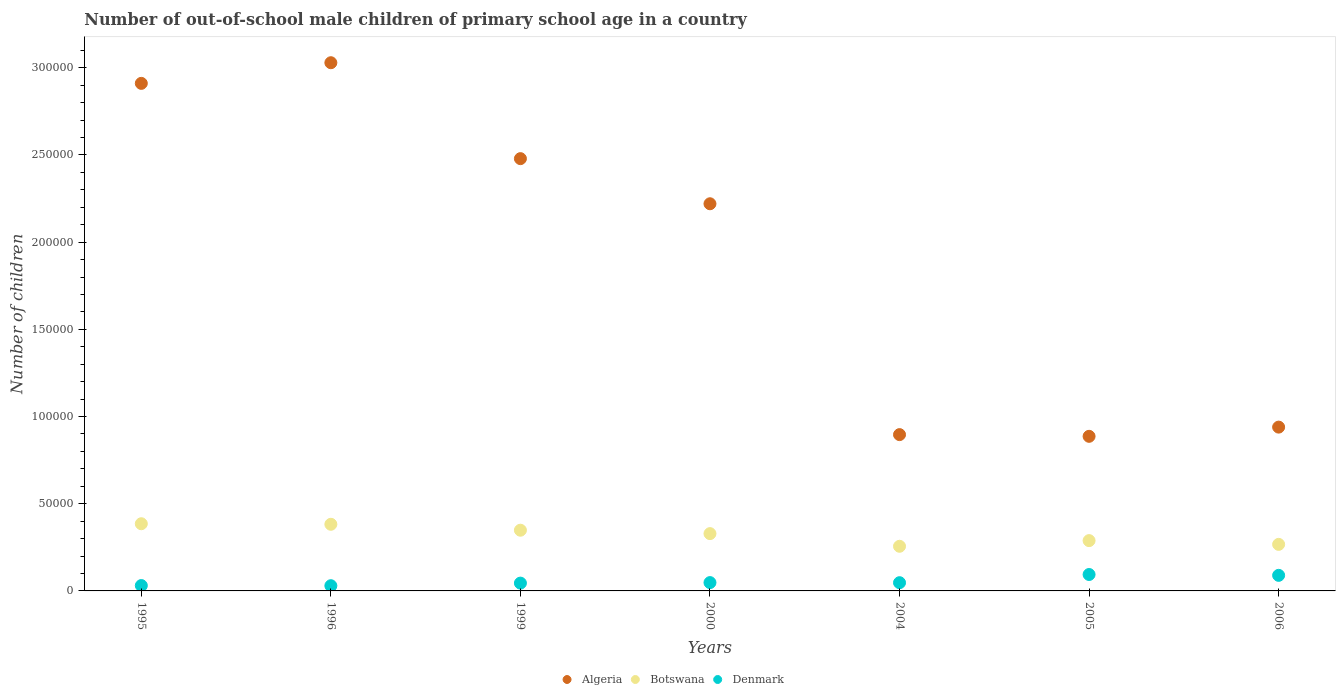How many different coloured dotlines are there?
Offer a very short reply. 3. Is the number of dotlines equal to the number of legend labels?
Offer a terse response. Yes. What is the number of out-of-school male children in Denmark in 1999?
Ensure brevity in your answer.  4475. Across all years, what is the maximum number of out-of-school male children in Botswana?
Provide a succinct answer. 3.85e+04. Across all years, what is the minimum number of out-of-school male children in Denmark?
Ensure brevity in your answer.  2986. In which year was the number of out-of-school male children in Algeria minimum?
Ensure brevity in your answer.  2005. What is the total number of out-of-school male children in Botswana in the graph?
Provide a short and direct response. 2.26e+05. What is the difference between the number of out-of-school male children in Denmark in 2004 and that in 2006?
Make the answer very short. -4213. What is the difference between the number of out-of-school male children in Denmark in 2005 and the number of out-of-school male children in Botswana in 1996?
Offer a terse response. -2.88e+04. What is the average number of out-of-school male children in Algeria per year?
Offer a very short reply. 1.91e+05. In the year 1996, what is the difference between the number of out-of-school male children in Denmark and number of out-of-school male children in Algeria?
Ensure brevity in your answer.  -3.00e+05. What is the ratio of the number of out-of-school male children in Denmark in 1995 to that in 2005?
Your response must be concise. 0.33. Is the number of out-of-school male children in Algeria in 2000 less than that in 2004?
Provide a succinct answer. No. What is the difference between the highest and the second highest number of out-of-school male children in Algeria?
Give a very brief answer. 1.18e+04. What is the difference between the highest and the lowest number of out-of-school male children in Denmark?
Offer a terse response. 6429. In how many years, is the number of out-of-school male children in Botswana greater than the average number of out-of-school male children in Botswana taken over all years?
Give a very brief answer. 4. Does the number of out-of-school male children in Algeria monotonically increase over the years?
Provide a succinct answer. No. How many dotlines are there?
Offer a very short reply. 3. What is the difference between two consecutive major ticks on the Y-axis?
Ensure brevity in your answer.  5.00e+04. Does the graph contain any zero values?
Ensure brevity in your answer.  No. Does the graph contain grids?
Ensure brevity in your answer.  No. Where does the legend appear in the graph?
Offer a very short reply. Bottom center. How many legend labels are there?
Provide a succinct answer. 3. How are the legend labels stacked?
Your response must be concise. Horizontal. What is the title of the graph?
Your response must be concise. Number of out-of-school male children of primary school age in a country. Does "Latin America(all income levels)" appear as one of the legend labels in the graph?
Provide a short and direct response. No. What is the label or title of the X-axis?
Give a very brief answer. Years. What is the label or title of the Y-axis?
Make the answer very short. Number of children. What is the Number of children of Algeria in 1995?
Offer a very short reply. 2.91e+05. What is the Number of children of Botswana in 1995?
Ensure brevity in your answer.  3.85e+04. What is the Number of children of Denmark in 1995?
Keep it short and to the point. 3071. What is the Number of children of Algeria in 1996?
Provide a succinct answer. 3.03e+05. What is the Number of children in Botswana in 1996?
Give a very brief answer. 3.82e+04. What is the Number of children of Denmark in 1996?
Your answer should be compact. 2986. What is the Number of children in Algeria in 1999?
Give a very brief answer. 2.48e+05. What is the Number of children of Botswana in 1999?
Provide a succinct answer. 3.48e+04. What is the Number of children of Denmark in 1999?
Give a very brief answer. 4475. What is the Number of children of Algeria in 2000?
Your answer should be compact. 2.22e+05. What is the Number of children of Botswana in 2000?
Your answer should be compact. 3.29e+04. What is the Number of children in Denmark in 2000?
Provide a succinct answer. 4775. What is the Number of children of Algeria in 2004?
Your answer should be very brief. 8.96e+04. What is the Number of children in Botswana in 2004?
Ensure brevity in your answer.  2.56e+04. What is the Number of children in Denmark in 2004?
Ensure brevity in your answer.  4718. What is the Number of children in Algeria in 2005?
Make the answer very short. 8.86e+04. What is the Number of children in Botswana in 2005?
Your answer should be very brief. 2.88e+04. What is the Number of children of Denmark in 2005?
Provide a succinct answer. 9415. What is the Number of children of Algeria in 2006?
Offer a terse response. 9.39e+04. What is the Number of children in Botswana in 2006?
Keep it short and to the point. 2.67e+04. What is the Number of children of Denmark in 2006?
Provide a succinct answer. 8931. Across all years, what is the maximum Number of children of Algeria?
Ensure brevity in your answer.  3.03e+05. Across all years, what is the maximum Number of children of Botswana?
Your answer should be compact. 3.85e+04. Across all years, what is the maximum Number of children of Denmark?
Ensure brevity in your answer.  9415. Across all years, what is the minimum Number of children of Algeria?
Your answer should be compact. 8.86e+04. Across all years, what is the minimum Number of children of Botswana?
Ensure brevity in your answer.  2.56e+04. Across all years, what is the minimum Number of children of Denmark?
Offer a very short reply. 2986. What is the total Number of children of Algeria in the graph?
Provide a short and direct response. 1.34e+06. What is the total Number of children in Botswana in the graph?
Ensure brevity in your answer.  2.26e+05. What is the total Number of children in Denmark in the graph?
Provide a short and direct response. 3.84e+04. What is the difference between the Number of children of Algeria in 1995 and that in 1996?
Keep it short and to the point. -1.18e+04. What is the difference between the Number of children in Botswana in 1995 and that in 1996?
Provide a short and direct response. 314. What is the difference between the Number of children of Algeria in 1995 and that in 1999?
Provide a succinct answer. 4.32e+04. What is the difference between the Number of children of Botswana in 1995 and that in 1999?
Offer a terse response. 3712. What is the difference between the Number of children of Denmark in 1995 and that in 1999?
Offer a terse response. -1404. What is the difference between the Number of children of Algeria in 1995 and that in 2000?
Offer a very short reply. 6.90e+04. What is the difference between the Number of children of Botswana in 1995 and that in 2000?
Provide a succinct answer. 5669. What is the difference between the Number of children of Denmark in 1995 and that in 2000?
Provide a short and direct response. -1704. What is the difference between the Number of children of Algeria in 1995 and that in 2004?
Give a very brief answer. 2.01e+05. What is the difference between the Number of children of Botswana in 1995 and that in 2004?
Keep it short and to the point. 1.29e+04. What is the difference between the Number of children of Denmark in 1995 and that in 2004?
Provide a short and direct response. -1647. What is the difference between the Number of children in Algeria in 1995 and that in 2005?
Your answer should be compact. 2.02e+05. What is the difference between the Number of children of Botswana in 1995 and that in 2005?
Make the answer very short. 9678. What is the difference between the Number of children in Denmark in 1995 and that in 2005?
Give a very brief answer. -6344. What is the difference between the Number of children of Algeria in 1995 and that in 2006?
Offer a terse response. 1.97e+05. What is the difference between the Number of children in Botswana in 1995 and that in 2006?
Offer a terse response. 1.18e+04. What is the difference between the Number of children of Denmark in 1995 and that in 2006?
Offer a very short reply. -5860. What is the difference between the Number of children in Algeria in 1996 and that in 1999?
Keep it short and to the point. 5.50e+04. What is the difference between the Number of children of Botswana in 1996 and that in 1999?
Make the answer very short. 3398. What is the difference between the Number of children of Denmark in 1996 and that in 1999?
Offer a very short reply. -1489. What is the difference between the Number of children in Algeria in 1996 and that in 2000?
Provide a short and direct response. 8.09e+04. What is the difference between the Number of children in Botswana in 1996 and that in 2000?
Provide a succinct answer. 5355. What is the difference between the Number of children of Denmark in 1996 and that in 2000?
Provide a succinct answer. -1789. What is the difference between the Number of children in Algeria in 1996 and that in 2004?
Your answer should be very brief. 2.13e+05. What is the difference between the Number of children in Botswana in 1996 and that in 2004?
Give a very brief answer. 1.26e+04. What is the difference between the Number of children in Denmark in 1996 and that in 2004?
Your answer should be very brief. -1732. What is the difference between the Number of children in Algeria in 1996 and that in 2005?
Provide a short and direct response. 2.14e+05. What is the difference between the Number of children of Botswana in 1996 and that in 2005?
Provide a short and direct response. 9364. What is the difference between the Number of children of Denmark in 1996 and that in 2005?
Provide a succinct answer. -6429. What is the difference between the Number of children of Algeria in 1996 and that in 2006?
Provide a short and direct response. 2.09e+05. What is the difference between the Number of children of Botswana in 1996 and that in 2006?
Ensure brevity in your answer.  1.15e+04. What is the difference between the Number of children in Denmark in 1996 and that in 2006?
Provide a short and direct response. -5945. What is the difference between the Number of children of Algeria in 1999 and that in 2000?
Make the answer very short. 2.59e+04. What is the difference between the Number of children of Botswana in 1999 and that in 2000?
Your answer should be very brief. 1957. What is the difference between the Number of children in Denmark in 1999 and that in 2000?
Give a very brief answer. -300. What is the difference between the Number of children in Algeria in 1999 and that in 2004?
Ensure brevity in your answer.  1.58e+05. What is the difference between the Number of children of Botswana in 1999 and that in 2004?
Ensure brevity in your answer.  9215. What is the difference between the Number of children in Denmark in 1999 and that in 2004?
Keep it short and to the point. -243. What is the difference between the Number of children in Algeria in 1999 and that in 2005?
Provide a succinct answer. 1.59e+05. What is the difference between the Number of children of Botswana in 1999 and that in 2005?
Your response must be concise. 5966. What is the difference between the Number of children in Denmark in 1999 and that in 2005?
Your answer should be compact. -4940. What is the difference between the Number of children of Algeria in 1999 and that in 2006?
Make the answer very short. 1.54e+05. What is the difference between the Number of children in Botswana in 1999 and that in 2006?
Offer a terse response. 8118. What is the difference between the Number of children in Denmark in 1999 and that in 2006?
Give a very brief answer. -4456. What is the difference between the Number of children of Algeria in 2000 and that in 2004?
Offer a very short reply. 1.32e+05. What is the difference between the Number of children in Botswana in 2000 and that in 2004?
Offer a terse response. 7258. What is the difference between the Number of children in Denmark in 2000 and that in 2004?
Keep it short and to the point. 57. What is the difference between the Number of children in Algeria in 2000 and that in 2005?
Keep it short and to the point. 1.33e+05. What is the difference between the Number of children of Botswana in 2000 and that in 2005?
Offer a very short reply. 4009. What is the difference between the Number of children of Denmark in 2000 and that in 2005?
Provide a succinct answer. -4640. What is the difference between the Number of children of Algeria in 2000 and that in 2006?
Your answer should be compact. 1.28e+05. What is the difference between the Number of children of Botswana in 2000 and that in 2006?
Provide a short and direct response. 6161. What is the difference between the Number of children of Denmark in 2000 and that in 2006?
Provide a short and direct response. -4156. What is the difference between the Number of children in Algeria in 2004 and that in 2005?
Offer a terse response. 978. What is the difference between the Number of children of Botswana in 2004 and that in 2005?
Your answer should be very brief. -3249. What is the difference between the Number of children of Denmark in 2004 and that in 2005?
Keep it short and to the point. -4697. What is the difference between the Number of children of Algeria in 2004 and that in 2006?
Make the answer very short. -4301. What is the difference between the Number of children of Botswana in 2004 and that in 2006?
Your answer should be very brief. -1097. What is the difference between the Number of children of Denmark in 2004 and that in 2006?
Make the answer very short. -4213. What is the difference between the Number of children in Algeria in 2005 and that in 2006?
Make the answer very short. -5279. What is the difference between the Number of children of Botswana in 2005 and that in 2006?
Keep it short and to the point. 2152. What is the difference between the Number of children in Denmark in 2005 and that in 2006?
Ensure brevity in your answer.  484. What is the difference between the Number of children in Algeria in 1995 and the Number of children in Botswana in 1996?
Keep it short and to the point. 2.53e+05. What is the difference between the Number of children in Algeria in 1995 and the Number of children in Denmark in 1996?
Keep it short and to the point. 2.88e+05. What is the difference between the Number of children in Botswana in 1995 and the Number of children in Denmark in 1996?
Give a very brief answer. 3.55e+04. What is the difference between the Number of children in Algeria in 1995 and the Number of children in Botswana in 1999?
Ensure brevity in your answer.  2.56e+05. What is the difference between the Number of children in Algeria in 1995 and the Number of children in Denmark in 1999?
Your answer should be very brief. 2.87e+05. What is the difference between the Number of children in Botswana in 1995 and the Number of children in Denmark in 1999?
Your response must be concise. 3.41e+04. What is the difference between the Number of children of Algeria in 1995 and the Number of children of Botswana in 2000?
Provide a succinct answer. 2.58e+05. What is the difference between the Number of children of Algeria in 1995 and the Number of children of Denmark in 2000?
Your answer should be very brief. 2.86e+05. What is the difference between the Number of children of Botswana in 1995 and the Number of children of Denmark in 2000?
Keep it short and to the point. 3.38e+04. What is the difference between the Number of children in Algeria in 1995 and the Number of children in Botswana in 2004?
Your answer should be very brief. 2.65e+05. What is the difference between the Number of children of Algeria in 1995 and the Number of children of Denmark in 2004?
Offer a terse response. 2.86e+05. What is the difference between the Number of children in Botswana in 1995 and the Number of children in Denmark in 2004?
Give a very brief answer. 3.38e+04. What is the difference between the Number of children in Algeria in 1995 and the Number of children in Botswana in 2005?
Give a very brief answer. 2.62e+05. What is the difference between the Number of children in Algeria in 1995 and the Number of children in Denmark in 2005?
Keep it short and to the point. 2.82e+05. What is the difference between the Number of children in Botswana in 1995 and the Number of children in Denmark in 2005?
Your response must be concise. 2.91e+04. What is the difference between the Number of children in Algeria in 1995 and the Number of children in Botswana in 2006?
Provide a short and direct response. 2.64e+05. What is the difference between the Number of children of Algeria in 1995 and the Number of children of Denmark in 2006?
Provide a succinct answer. 2.82e+05. What is the difference between the Number of children of Botswana in 1995 and the Number of children of Denmark in 2006?
Your answer should be compact. 2.96e+04. What is the difference between the Number of children of Algeria in 1996 and the Number of children of Botswana in 1999?
Provide a short and direct response. 2.68e+05. What is the difference between the Number of children of Algeria in 1996 and the Number of children of Denmark in 1999?
Give a very brief answer. 2.98e+05. What is the difference between the Number of children in Botswana in 1996 and the Number of children in Denmark in 1999?
Provide a succinct answer. 3.37e+04. What is the difference between the Number of children of Algeria in 1996 and the Number of children of Botswana in 2000?
Keep it short and to the point. 2.70e+05. What is the difference between the Number of children of Algeria in 1996 and the Number of children of Denmark in 2000?
Your answer should be very brief. 2.98e+05. What is the difference between the Number of children in Botswana in 1996 and the Number of children in Denmark in 2000?
Your response must be concise. 3.34e+04. What is the difference between the Number of children of Algeria in 1996 and the Number of children of Botswana in 2004?
Offer a very short reply. 2.77e+05. What is the difference between the Number of children in Algeria in 1996 and the Number of children in Denmark in 2004?
Ensure brevity in your answer.  2.98e+05. What is the difference between the Number of children in Botswana in 1996 and the Number of children in Denmark in 2004?
Keep it short and to the point. 3.35e+04. What is the difference between the Number of children in Algeria in 1996 and the Number of children in Botswana in 2005?
Keep it short and to the point. 2.74e+05. What is the difference between the Number of children of Algeria in 1996 and the Number of children of Denmark in 2005?
Your answer should be very brief. 2.93e+05. What is the difference between the Number of children of Botswana in 1996 and the Number of children of Denmark in 2005?
Keep it short and to the point. 2.88e+04. What is the difference between the Number of children of Algeria in 1996 and the Number of children of Botswana in 2006?
Keep it short and to the point. 2.76e+05. What is the difference between the Number of children of Algeria in 1996 and the Number of children of Denmark in 2006?
Your answer should be very brief. 2.94e+05. What is the difference between the Number of children in Botswana in 1996 and the Number of children in Denmark in 2006?
Make the answer very short. 2.93e+04. What is the difference between the Number of children in Algeria in 1999 and the Number of children in Botswana in 2000?
Your answer should be compact. 2.15e+05. What is the difference between the Number of children in Algeria in 1999 and the Number of children in Denmark in 2000?
Ensure brevity in your answer.  2.43e+05. What is the difference between the Number of children of Botswana in 1999 and the Number of children of Denmark in 2000?
Your answer should be very brief. 3.00e+04. What is the difference between the Number of children in Algeria in 1999 and the Number of children in Botswana in 2004?
Keep it short and to the point. 2.22e+05. What is the difference between the Number of children in Algeria in 1999 and the Number of children in Denmark in 2004?
Keep it short and to the point. 2.43e+05. What is the difference between the Number of children in Botswana in 1999 and the Number of children in Denmark in 2004?
Ensure brevity in your answer.  3.01e+04. What is the difference between the Number of children of Algeria in 1999 and the Number of children of Botswana in 2005?
Your answer should be compact. 2.19e+05. What is the difference between the Number of children in Algeria in 1999 and the Number of children in Denmark in 2005?
Offer a very short reply. 2.38e+05. What is the difference between the Number of children in Botswana in 1999 and the Number of children in Denmark in 2005?
Your answer should be compact. 2.54e+04. What is the difference between the Number of children in Algeria in 1999 and the Number of children in Botswana in 2006?
Your answer should be very brief. 2.21e+05. What is the difference between the Number of children of Algeria in 1999 and the Number of children of Denmark in 2006?
Your answer should be very brief. 2.39e+05. What is the difference between the Number of children of Botswana in 1999 and the Number of children of Denmark in 2006?
Provide a short and direct response. 2.59e+04. What is the difference between the Number of children in Algeria in 2000 and the Number of children in Botswana in 2004?
Give a very brief answer. 1.96e+05. What is the difference between the Number of children in Algeria in 2000 and the Number of children in Denmark in 2004?
Give a very brief answer. 2.17e+05. What is the difference between the Number of children of Botswana in 2000 and the Number of children of Denmark in 2004?
Make the answer very short. 2.81e+04. What is the difference between the Number of children of Algeria in 2000 and the Number of children of Botswana in 2005?
Provide a short and direct response. 1.93e+05. What is the difference between the Number of children in Algeria in 2000 and the Number of children in Denmark in 2005?
Make the answer very short. 2.13e+05. What is the difference between the Number of children of Botswana in 2000 and the Number of children of Denmark in 2005?
Offer a very short reply. 2.34e+04. What is the difference between the Number of children in Algeria in 2000 and the Number of children in Botswana in 2006?
Keep it short and to the point. 1.95e+05. What is the difference between the Number of children of Algeria in 2000 and the Number of children of Denmark in 2006?
Keep it short and to the point. 2.13e+05. What is the difference between the Number of children in Botswana in 2000 and the Number of children in Denmark in 2006?
Make the answer very short. 2.39e+04. What is the difference between the Number of children in Algeria in 2004 and the Number of children in Botswana in 2005?
Ensure brevity in your answer.  6.08e+04. What is the difference between the Number of children in Algeria in 2004 and the Number of children in Denmark in 2005?
Keep it short and to the point. 8.02e+04. What is the difference between the Number of children in Botswana in 2004 and the Number of children in Denmark in 2005?
Make the answer very short. 1.62e+04. What is the difference between the Number of children of Algeria in 2004 and the Number of children of Botswana in 2006?
Keep it short and to the point. 6.29e+04. What is the difference between the Number of children of Algeria in 2004 and the Number of children of Denmark in 2006?
Your response must be concise. 8.07e+04. What is the difference between the Number of children of Botswana in 2004 and the Number of children of Denmark in 2006?
Your response must be concise. 1.67e+04. What is the difference between the Number of children in Algeria in 2005 and the Number of children in Botswana in 2006?
Offer a terse response. 6.20e+04. What is the difference between the Number of children of Algeria in 2005 and the Number of children of Denmark in 2006?
Your answer should be compact. 7.97e+04. What is the difference between the Number of children in Botswana in 2005 and the Number of children in Denmark in 2006?
Ensure brevity in your answer.  1.99e+04. What is the average Number of children in Algeria per year?
Your answer should be compact. 1.91e+05. What is the average Number of children of Botswana per year?
Keep it short and to the point. 3.22e+04. What is the average Number of children in Denmark per year?
Provide a short and direct response. 5481.57. In the year 1995, what is the difference between the Number of children of Algeria and Number of children of Botswana?
Make the answer very short. 2.53e+05. In the year 1995, what is the difference between the Number of children of Algeria and Number of children of Denmark?
Make the answer very short. 2.88e+05. In the year 1995, what is the difference between the Number of children of Botswana and Number of children of Denmark?
Offer a very short reply. 3.55e+04. In the year 1996, what is the difference between the Number of children in Algeria and Number of children in Botswana?
Keep it short and to the point. 2.65e+05. In the year 1996, what is the difference between the Number of children of Algeria and Number of children of Denmark?
Your answer should be compact. 3.00e+05. In the year 1996, what is the difference between the Number of children of Botswana and Number of children of Denmark?
Ensure brevity in your answer.  3.52e+04. In the year 1999, what is the difference between the Number of children in Algeria and Number of children in Botswana?
Offer a terse response. 2.13e+05. In the year 1999, what is the difference between the Number of children of Algeria and Number of children of Denmark?
Provide a succinct answer. 2.43e+05. In the year 1999, what is the difference between the Number of children in Botswana and Number of children in Denmark?
Your response must be concise. 3.03e+04. In the year 2000, what is the difference between the Number of children in Algeria and Number of children in Botswana?
Ensure brevity in your answer.  1.89e+05. In the year 2000, what is the difference between the Number of children in Algeria and Number of children in Denmark?
Your answer should be very brief. 2.17e+05. In the year 2000, what is the difference between the Number of children in Botswana and Number of children in Denmark?
Provide a short and direct response. 2.81e+04. In the year 2004, what is the difference between the Number of children in Algeria and Number of children in Botswana?
Provide a short and direct response. 6.40e+04. In the year 2004, what is the difference between the Number of children of Algeria and Number of children of Denmark?
Your answer should be very brief. 8.49e+04. In the year 2004, what is the difference between the Number of children of Botswana and Number of children of Denmark?
Ensure brevity in your answer.  2.09e+04. In the year 2005, what is the difference between the Number of children of Algeria and Number of children of Botswana?
Your response must be concise. 5.98e+04. In the year 2005, what is the difference between the Number of children in Algeria and Number of children in Denmark?
Provide a succinct answer. 7.92e+04. In the year 2005, what is the difference between the Number of children of Botswana and Number of children of Denmark?
Offer a very short reply. 1.94e+04. In the year 2006, what is the difference between the Number of children in Algeria and Number of children in Botswana?
Offer a terse response. 6.72e+04. In the year 2006, what is the difference between the Number of children of Algeria and Number of children of Denmark?
Provide a succinct answer. 8.50e+04. In the year 2006, what is the difference between the Number of children in Botswana and Number of children in Denmark?
Ensure brevity in your answer.  1.78e+04. What is the ratio of the Number of children in Algeria in 1995 to that in 1996?
Keep it short and to the point. 0.96. What is the ratio of the Number of children of Botswana in 1995 to that in 1996?
Give a very brief answer. 1.01. What is the ratio of the Number of children in Denmark in 1995 to that in 1996?
Provide a short and direct response. 1.03. What is the ratio of the Number of children of Algeria in 1995 to that in 1999?
Keep it short and to the point. 1.17. What is the ratio of the Number of children of Botswana in 1995 to that in 1999?
Make the answer very short. 1.11. What is the ratio of the Number of children in Denmark in 1995 to that in 1999?
Keep it short and to the point. 0.69. What is the ratio of the Number of children in Algeria in 1995 to that in 2000?
Keep it short and to the point. 1.31. What is the ratio of the Number of children of Botswana in 1995 to that in 2000?
Keep it short and to the point. 1.17. What is the ratio of the Number of children of Denmark in 1995 to that in 2000?
Ensure brevity in your answer.  0.64. What is the ratio of the Number of children of Algeria in 1995 to that in 2004?
Keep it short and to the point. 3.25. What is the ratio of the Number of children of Botswana in 1995 to that in 2004?
Your response must be concise. 1.5. What is the ratio of the Number of children in Denmark in 1995 to that in 2004?
Give a very brief answer. 0.65. What is the ratio of the Number of children of Algeria in 1995 to that in 2005?
Your response must be concise. 3.28. What is the ratio of the Number of children of Botswana in 1995 to that in 2005?
Make the answer very short. 1.34. What is the ratio of the Number of children in Denmark in 1995 to that in 2005?
Give a very brief answer. 0.33. What is the ratio of the Number of children of Algeria in 1995 to that in 2006?
Make the answer very short. 3.1. What is the ratio of the Number of children in Botswana in 1995 to that in 2006?
Your response must be concise. 1.44. What is the ratio of the Number of children of Denmark in 1995 to that in 2006?
Your answer should be very brief. 0.34. What is the ratio of the Number of children of Algeria in 1996 to that in 1999?
Offer a terse response. 1.22. What is the ratio of the Number of children of Botswana in 1996 to that in 1999?
Make the answer very short. 1.1. What is the ratio of the Number of children of Denmark in 1996 to that in 1999?
Offer a terse response. 0.67. What is the ratio of the Number of children in Algeria in 1996 to that in 2000?
Provide a succinct answer. 1.36. What is the ratio of the Number of children in Botswana in 1996 to that in 2000?
Ensure brevity in your answer.  1.16. What is the ratio of the Number of children in Denmark in 1996 to that in 2000?
Offer a very short reply. 0.63. What is the ratio of the Number of children in Algeria in 1996 to that in 2004?
Offer a very short reply. 3.38. What is the ratio of the Number of children of Botswana in 1996 to that in 2004?
Offer a terse response. 1.49. What is the ratio of the Number of children in Denmark in 1996 to that in 2004?
Ensure brevity in your answer.  0.63. What is the ratio of the Number of children of Algeria in 1996 to that in 2005?
Provide a succinct answer. 3.42. What is the ratio of the Number of children in Botswana in 1996 to that in 2005?
Provide a short and direct response. 1.32. What is the ratio of the Number of children of Denmark in 1996 to that in 2005?
Your response must be concise. 0.32. What is the ratio of the Number of children in Algeria in 1996 to that in 2006?
Offer a terse response. 3.22. What is the ratio of the Number of children in Botswana in 1996 to that in 2006?
Offer a terse response. 1.43. What is the ratio of the Number of children in Denmark in 1996 to that in 2006?
Provide a succinct answer. 0.33. What is the ratio of the Number of children of Algeria in 1999 to that in 2000?
Ensure brevity in your answer.  1.12. What is the ratio of the Number of children in Botswana in 1999 to that in 2000?
Make the answer very short. 1.06. What is the ratio of the Number of children in Denmark in 1999 to that in 2000?
Your answer should be very brief. 0.94. What is the ratio of the Number of children of Algeria in 1999 to that in 2004?
Provide a succinct answer. 2.77. What is the ratio of the Number of children in Botswana in 1999 to that in 2004?
Keep it short and to the point. 1.36. What is the ratio of the Number of children of Denmark in 1999 to that in 2004?
Your answer should be very brief. 0.95. What is the ratio of the Number of children in Algeria in 1999 to that in 2005?
Provide a short and direct response. 2.8. What is the ratio of the Number of children of Botswana in 1999 to that in 2005?
Your answer should be compact. 1.21. What is the ratio of the Number of children in Denmark in 1999 to that in 2005?
Provide a succinct answer. 0.48. What is the ratio of the Number of children in Algeria in 1999 to that in 2006?
Give a very brief answer. 2.64. What is the ratio of the Number of children of Botswana in 1999 to that in 2006?
Provide a succinct answer. 1.3. What is the ratio of the Number of children of Denmark in 1999 to that in 2006?
Keep it short and to the point. 0.5. What is the ratio of the Number of children in Algeria in 2000 to that in 2004?
Offer a terse response. 2.48. What is the ratio of the Number of children of Botswana in 2000 to that in 2004?
Your answer should be very brief. 1.28. What is the ratio of the Number of children in Denmark in 2000 to that in 2004?
Ensure brevity in your answer.  1.01. What is the ratio of the Number of children of Algeria in 2000 to that in 2005?
Keep it short and to the point. 2.5. What is the ratio of the Number of children of Botswana in 2000 to that in 2005?
Your response must be concise. 1.14. What is the ratio of the Number of children in Denmark in 2000 to that in 2005?
Your response must be concise. 0.51. What is the ratio of the Number of children in Algeria in 2000 to that in 2006?
Offer a very short reply. 2.36. What is the ratio of the Number of children of Botswana in 2000 to that in 2006?
Give a very brief answer. 1.23. What is the ratio of the Number of children in Denmark in 2000 to that in 2006?
Ensure brevity in your answer.  0.53. What is the ratio of the Number of children in Botswana in 2004 to that in 2005?
Offer a terse response. 0.89. What is the ratio of the Number of children of Denmark in 2004 to that in 2005?
Offer a terse response. 0.5. What is the ratio of the Number of children of Algeria in 2004 to that in 2006?
Provide a succinct answer. 0.95. What is the ratio of the Number of children of Botswana in 2004 to that in 2006?
Ensure brevity in your answer.  0.96. What is the ratio of the Number of children of Denmark in 2004 to that in 2006?
Provide a short and direct response. 0.53. What is the ratio of the Number of children in Algeria in 2005 to that in 2006?
Keep it short and to the point. 0.94. What is the ratio of the Number of children in Botswana in 2005 to that in 2006?
Keep it short and to the point. 1.08. What is the ratio of the Number of children of Denmark in 2005 to that in 2006?
Ensure brevity in your answer.  1.05. What is the difference between the highest and the second highest Number of children of Algeria?
Ensure brevity in your answer.  1.18e+04. What is the difference between the highest and the second highest Number of children in Botswana?
Give a very brief answer. 314. What is the difference between the highest and the second highest Number of children of Denmark?
Your answer should be compact. 484. What is the difference between the highest and the lowest Number of children in Algeria?
Your response must be concise. 2.14e+05. What is the difference between the highest and the lowest Number of children of Botswana?
Ensure brevity in your answer.  1.29e+04. What is the difference between the highest and the lowest Number of children in Denmark?
Provide a short and direct response. 6429. 